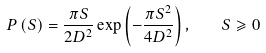Convert formula to latex. <formula><loc_0><loc_0><loc_500><loc_500>P \left ( S \right ) = \frac { \pi S } { 2 D ^ { 2 } } \exp \left ( { - \frac { \pi S ^ { 2 } } { 4 D ^ { 2 } } } \right ) , \quad S \geqslant 0</formula> 